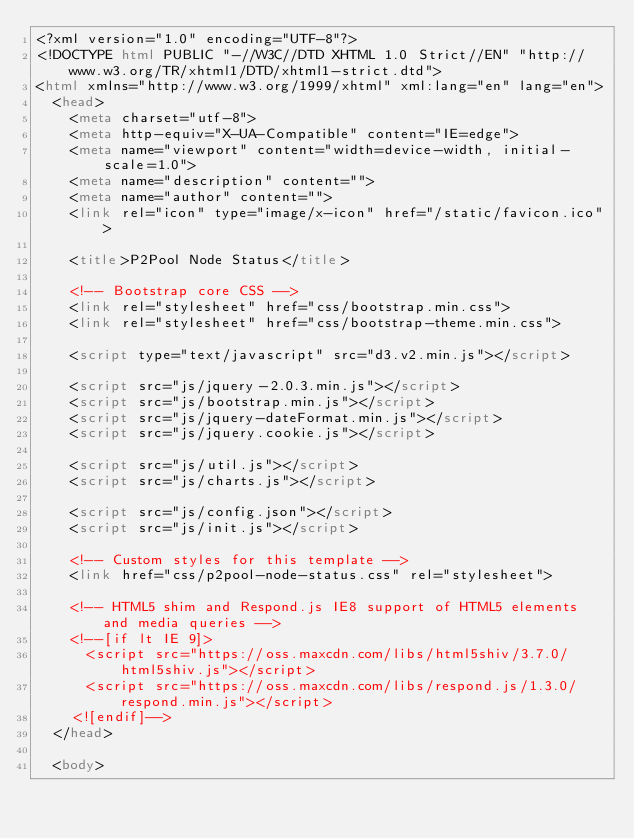<code> <loc_0><loc_0><loc_500><loc_500><_HTML_><?xml version="1.0" encoding="UTF-8"?>
<!DOCTYPE html PUBLIC "-//W3C//DTD XHTML 1.0 Strict//EN" "http://www.w3.org/TR/xhtml1/DTD/xhtml1-strict.dtd">
<html xmlns="http://www.w3.org/1999/xhtml" xml:lang="en" lang="en">
  <head>
    <meta charset="utf-8">
    <meta http-equiv="X-UA-Compatible" content="IE=edge">
    <meta name="viewport" content="width=device-width, initial-scale=1.0">
    <meta name="description" content="">
    <meta name="author" content="">
    <link rel="icon" type="image/x-icon" href="/static/favicon.ico">

    <title>P2Pool Node Status</title>

    <!-- Bootstrap core CSS -->
    <link rel="stylesheet" href="css/bootstrap.min.css">
    <link rel="stylesheet" href="css/bootstrap-theme.min.css">

    <script type="text/javascript" src="d3.v2.min.js"></script>

    <script src="js/jquery-2.0.3.min.js"></script>
    <script src="js/bootstrap.min.js"></script>
    <script src="js/jquery-dateFormat.min.js"></script>
    <script src="js/jquery.cookie.js"></script>

    <script src="js/util.js"></script>
    <script src="js/charts.js"></script>

    <script src="js/config.json"></script>
    <script src="js/init.js"></script>

    <!-- Custom styles for this template -->
    <link href="css/p2pool-node-status.css" rel="stylesheet">

    <!-- HTML5 shim and Respond.js IE8 support of HTML5 elements and media queries -->
    <!--[if lt IE 9]>
      <script src="https://oss.maxcdn.com/libs/html5shiv/3.7.0/html5shiv.js"></script>
      <script src="https://oss.maxcdn.com/libs/respond.js/1.3.0/respond.min.js"></script>
    <![endif]-->
  </head>

  <body></code> 